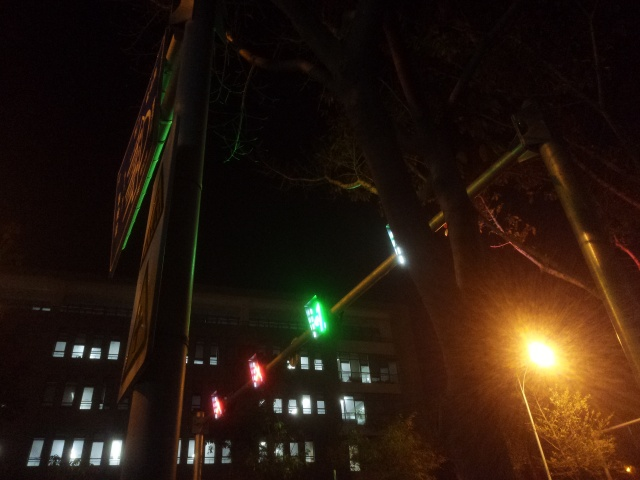Does the image have good clarity? The image's clarity is not ideal due to visible noise and low lighting, which could affect the visibility of finer details. Additionally, there's a noticeable level of graininess and a lack of sharp focus that might make it difficult to discern specific features or objects within the scene. 